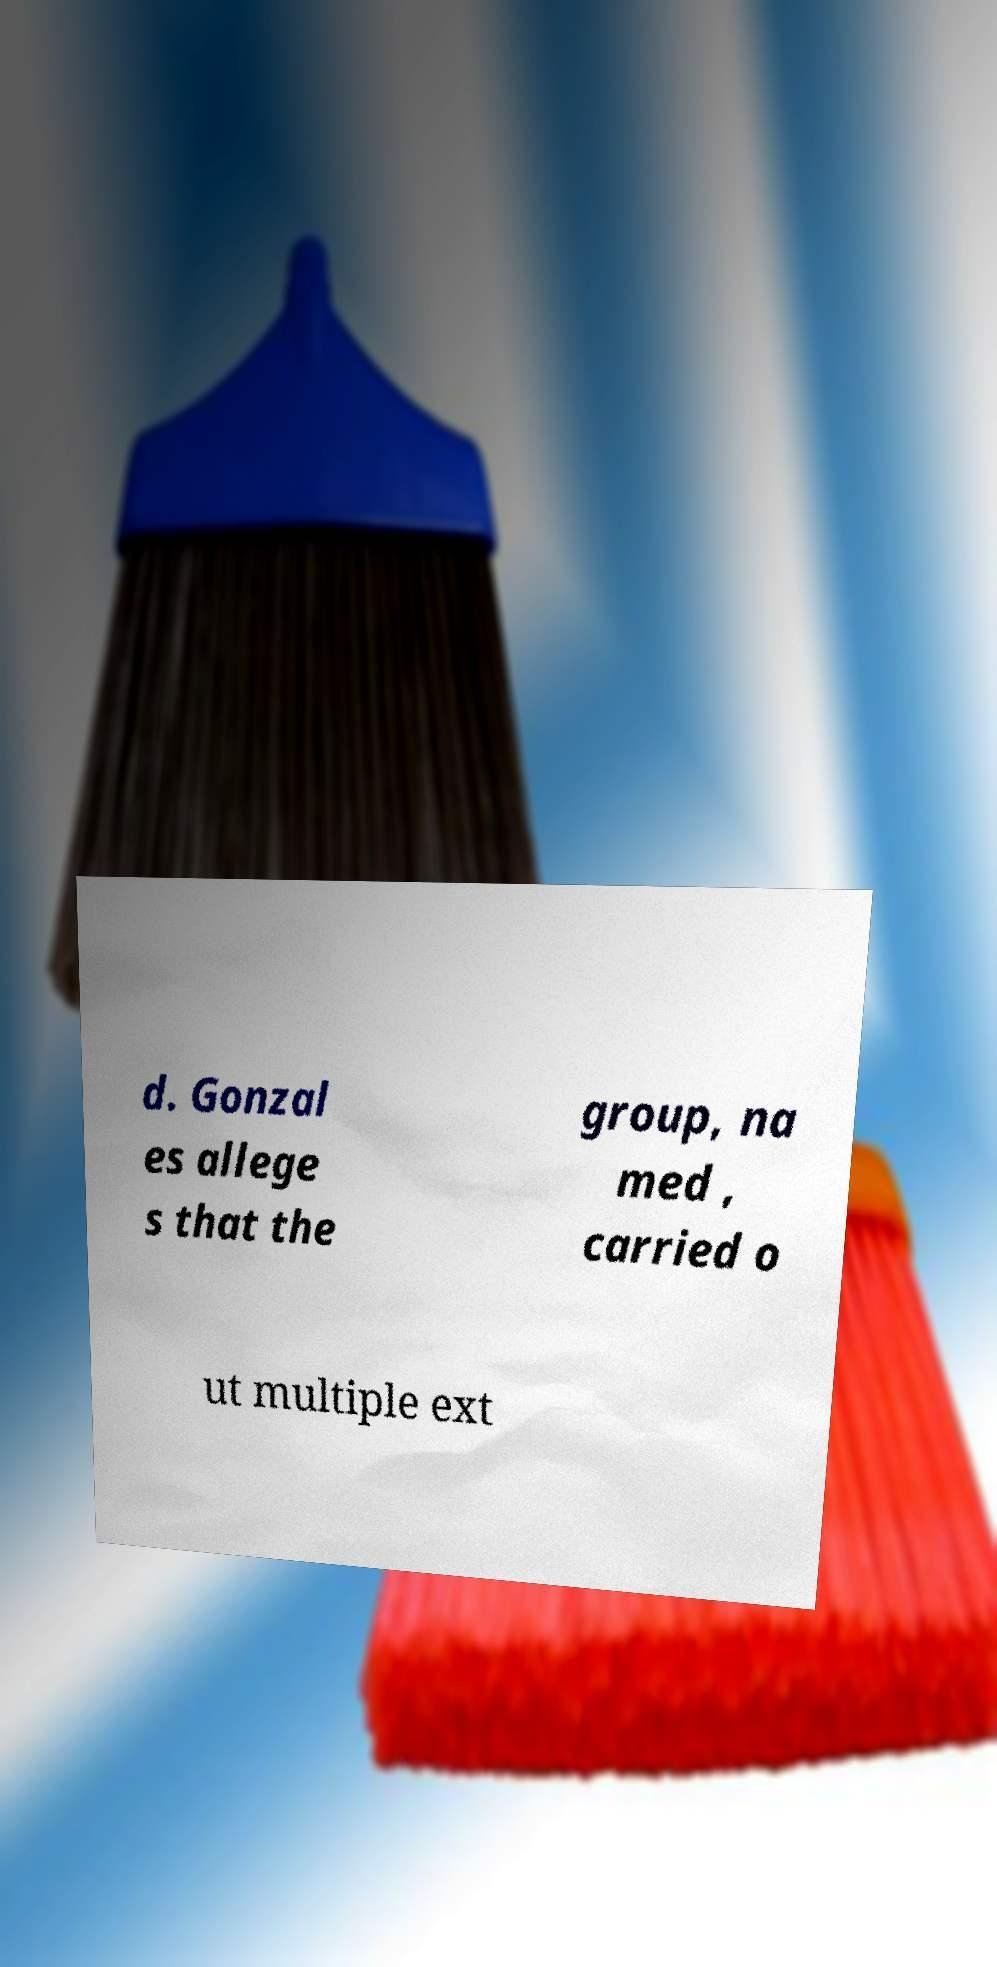Could you extract and type out the text from this image? d. Gonzal es allege s that the group, na med , carried o ut multiple ext 